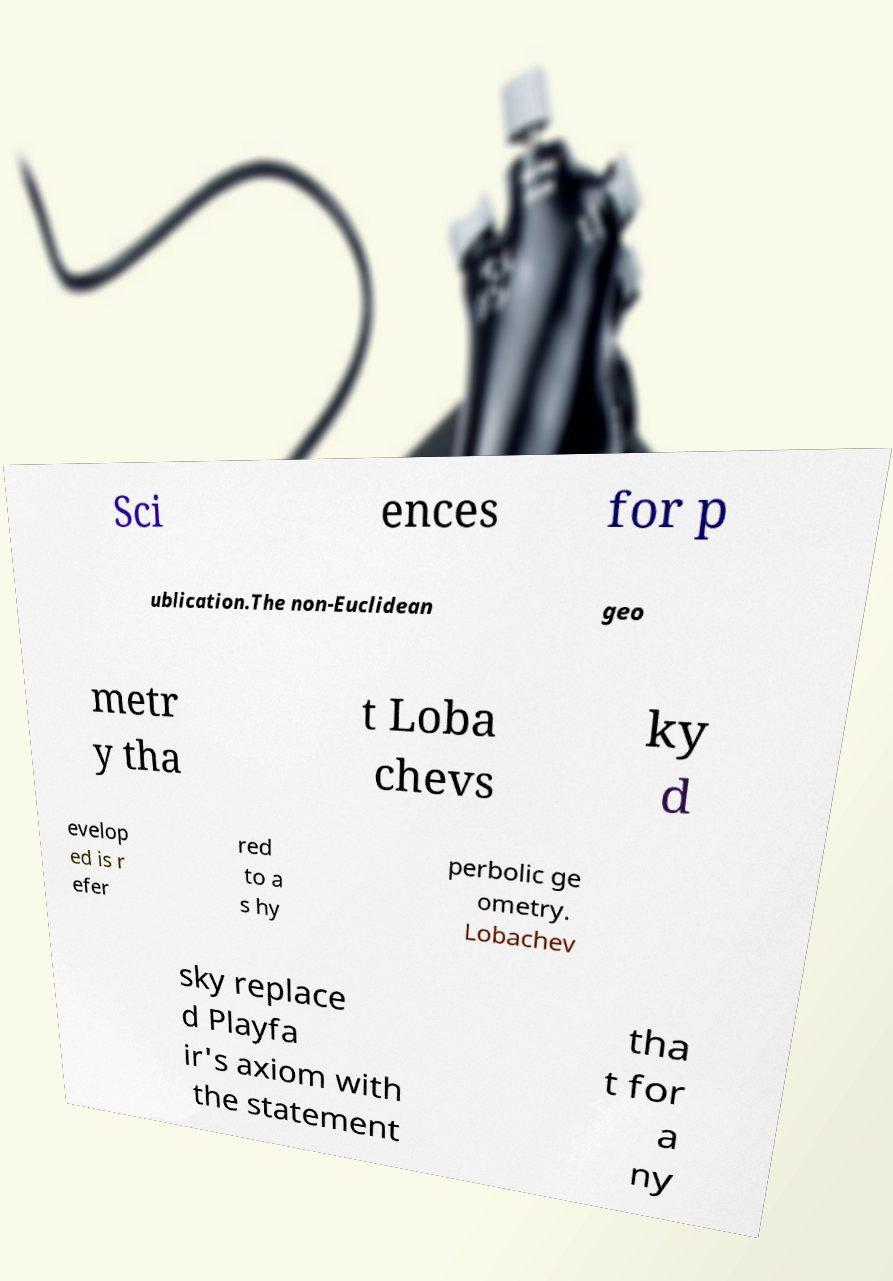What messages or text are displayed in this image? I need them in a readable, typed format. Sci ences for p ublication.The non-Euclidean geo metr y tha t Loba chevs ky d evelop ed is r efer red to a s hy perbolic ge ometry. Lobachev sky replace d Playfa ir's axiom with the statement tha t for a ny 